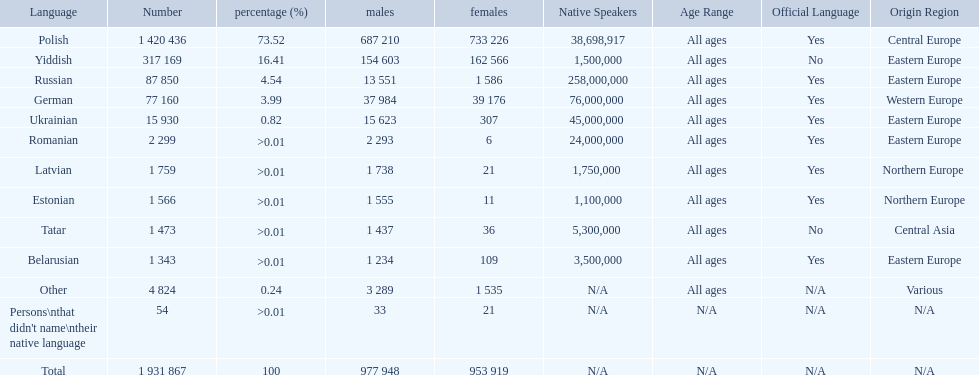What languages are spoken in the warsaw governorate? Polish, Yiddish, Russian, German, Ukrainian, Romanian, Latvian, Estonian, Tatar, Belarusian, Other, Persons\nthat didn't name\ntheir native language. What is the number for russian? 87 850. On this list what is the next lowest number? 77 160. Which language has a number of 77160 speakers? German. 